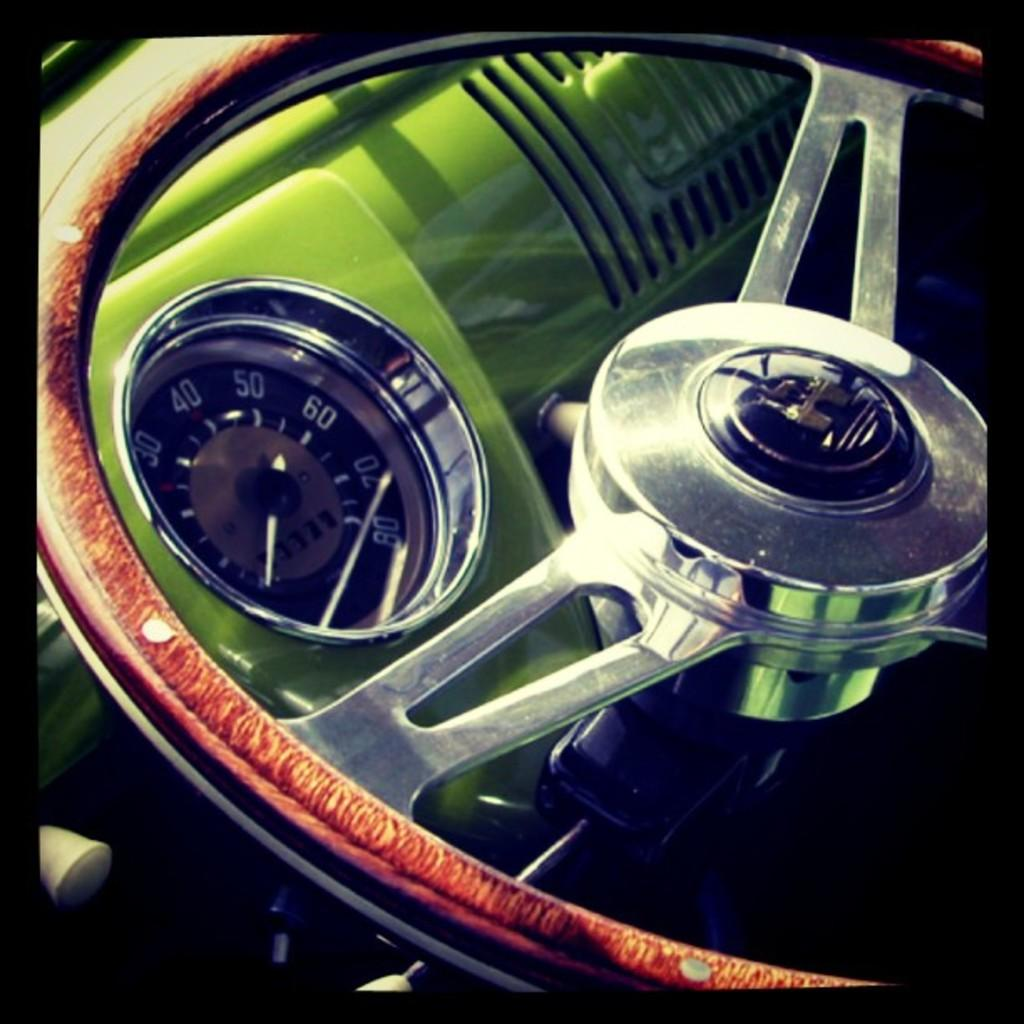What is the primary object in the image? There is a steering wheel in the image. What other objects can be seen in the image? There is a gauge and buttons in the image. How many toes are visible in the image? There are no toes visible in the image; it features a steering wheel, a gauge, and buttons. 